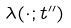Convert formula to latex. <formula><loc_0><loc_0><loc_500><loc_500>\lambda ( \cdot ; t ^ { \prime \prime } )</formula> 